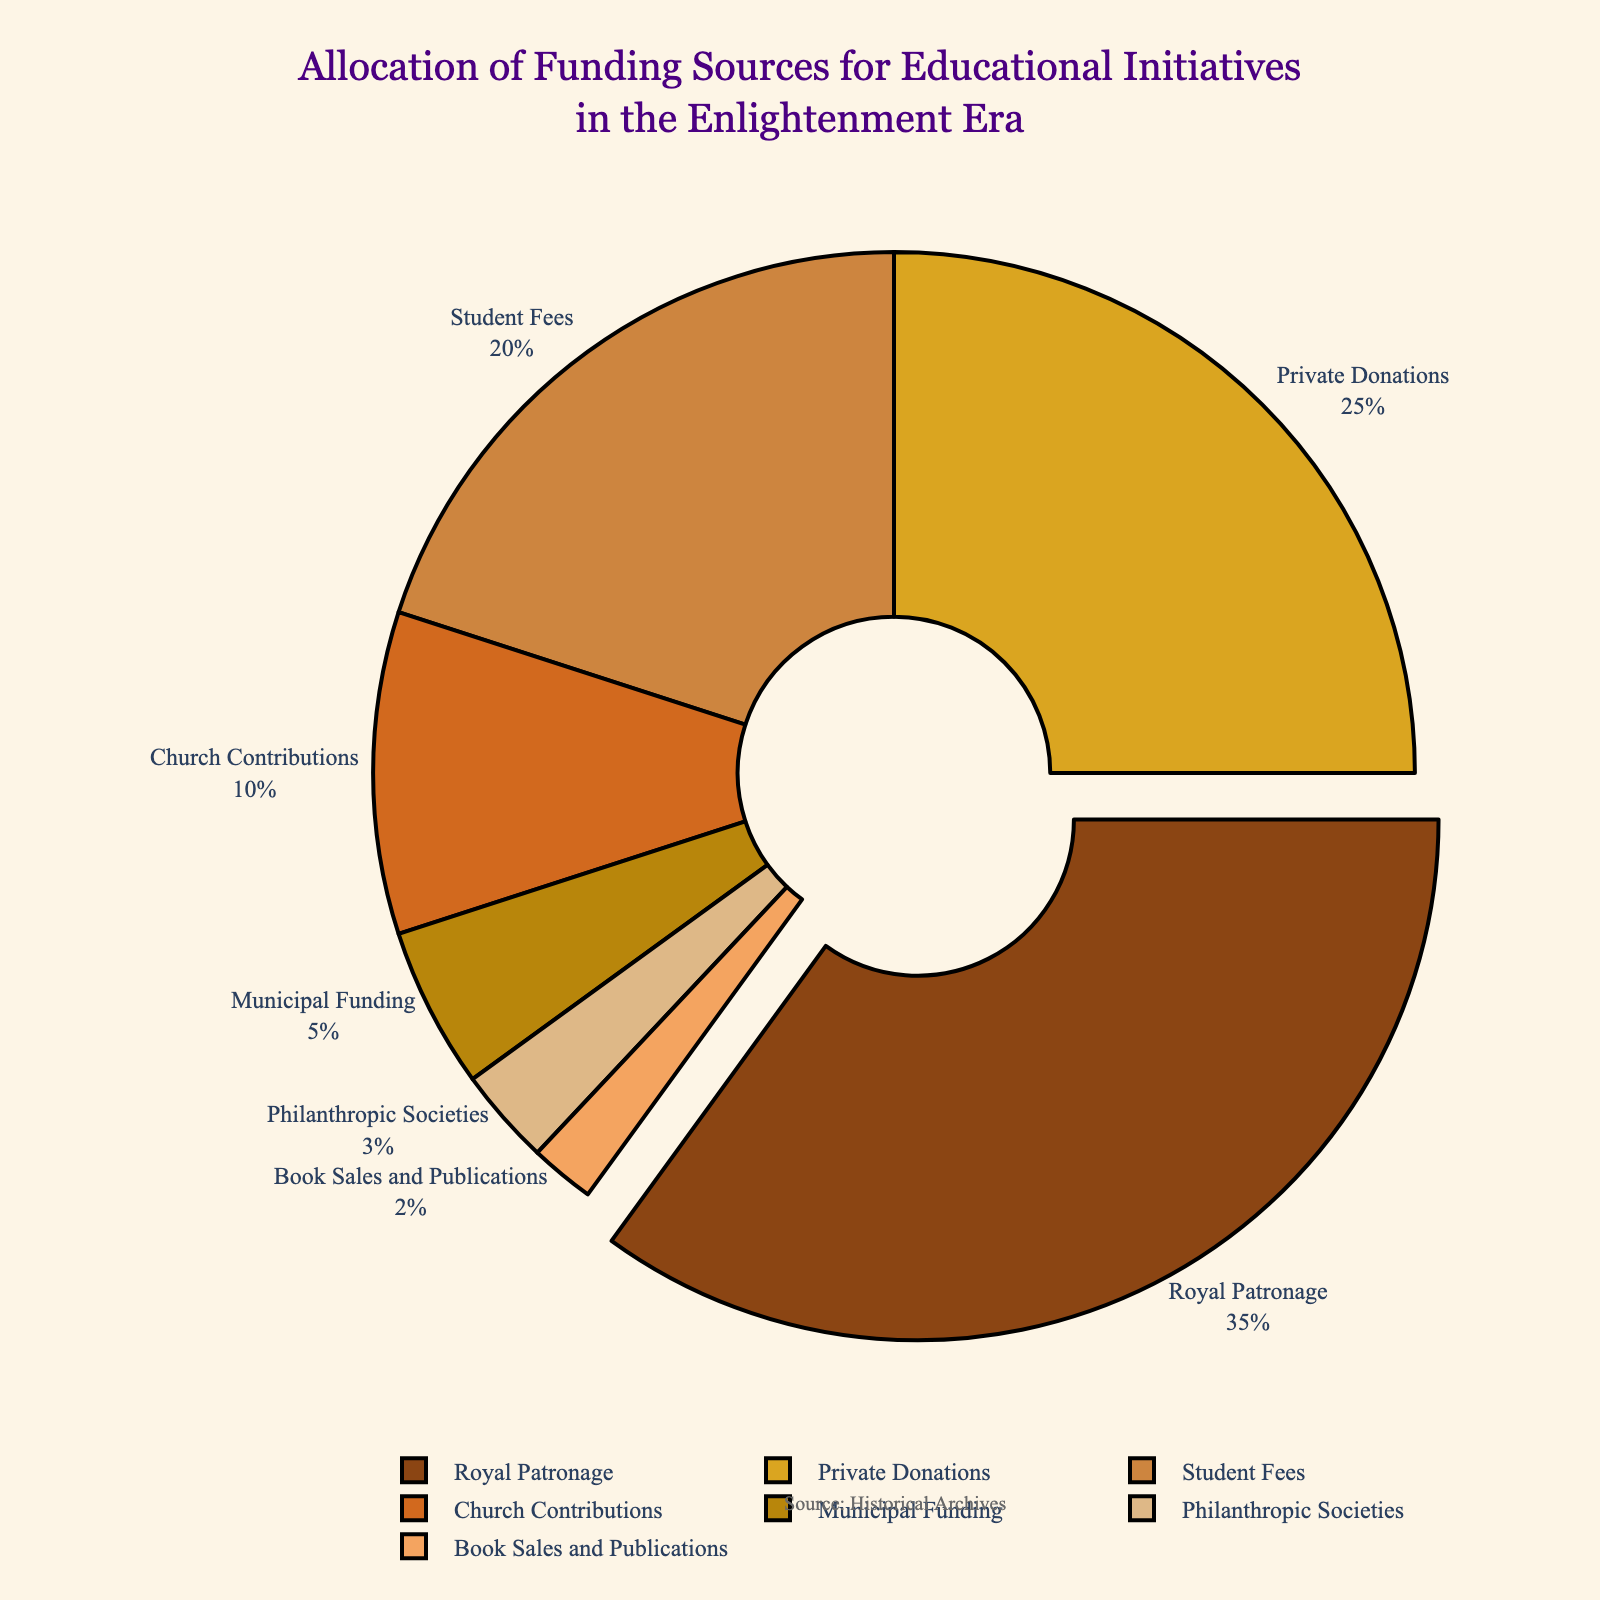What's the largest funding source for educational initiatives in the Enlightenment era? The largest funding source can be identified by looking at the section of the pie chart that is most prominent and slightly pulled out from the center. The magnified section labeled “Royal Patronage” accounts for 35% of the total, making it the largest funding source.
Answer: Royal Patronage What is the combined percentage of Private Donations and Student Fees? To find the combined percentage, sum the percentages that correspond to Private Donations and Student Fees. These are 25% and 20%, respectively. Adding them gives 25 + 20 = 45%.
Answer: 45% Which two funding sources combined contribute less than Church Contributions? First, observe that Church Contributions make up 10% of the funding. To find two sources that contribute less, look for the two smallest percentages from the pie chart: Philanthropic Societies (3%) and Book Sales and Publications (2%). Together, they constitute 3 + 2 = 5%, which is less than 10%.
Answer: Philanthropic Societies and Book Sales and Publications Which funding source is represented by the lightest shade of brown? The lightest shade of brown on the pie chart corresponds to the smallest section, labeled as “Book Sales and Publications,” which occupies 2% of the total.
Answer: Book Sales and Publications How much more significant is Municipal Funding compared to Book Sales and Publications? Municipal Funding accounts for 5%, while Book Sales and Publications comprise 2%. The difference is 5 - 2 = 3%.
Answer: 3% What is the total percentage contributed by sources exceeding 10% individually? Identify sources exceeding 10%, which are Royal Patronage (35%), Private Donations (25%), and Student Fees (20%). Add these percentages: 35 + 25 + 20 = 80%.
Answer: 80% If the funding from Royal Patronage decreased by 5%, would it still be the largest contributor? Royal Patronage currently represents 35%. If this is reduced by 5%, the new figure would be 35 - 5 = 30%. Private Donations at 25% and Student Fees at 20% still total less than 30%, meaning Royal Patronage remains the largest contributor, though by a smaller margin.
Answer: Yes Which category contributes almost four times as much as Philanthropic Societies? Philanthropic Societies provide 3%. The category contributing four times more would be 3 * 4 = 12%. The closest category, significantly exceeding 12%, is Church Contributions at 10%, but Student Fees at 20% are almost but under four times 3%.
Answer: Student Fees 